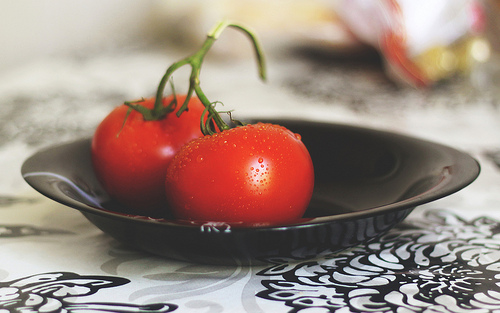<image>
Is there a tomato on the table? Yes. Looking at the image, I can see the tomato is positioned on top of the table, with the table providing support. Is the tomato next to the bowl? No. The tomato is not positioned next to the bowl. They are located in different areas of the scene. 